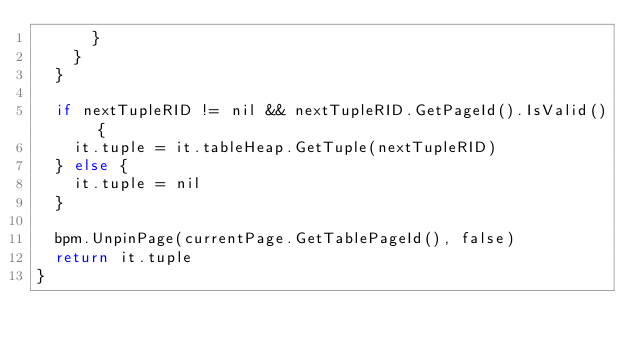<code> <loc_0><loc_0><loc_500><loc_500><_Go_>			}
		}
	}

	if nextTupleRID != nil && nextTupleRID.GetPageId().IsValid() {
		it.tuple = it.tableHeap.GetTuple(nextTupleRID)
	} else {
		it.tuple = nil
	}

	bpm.UnpinPage(currentPage.GetTablePageId(), false)
	return it.tuple
}
</code> 